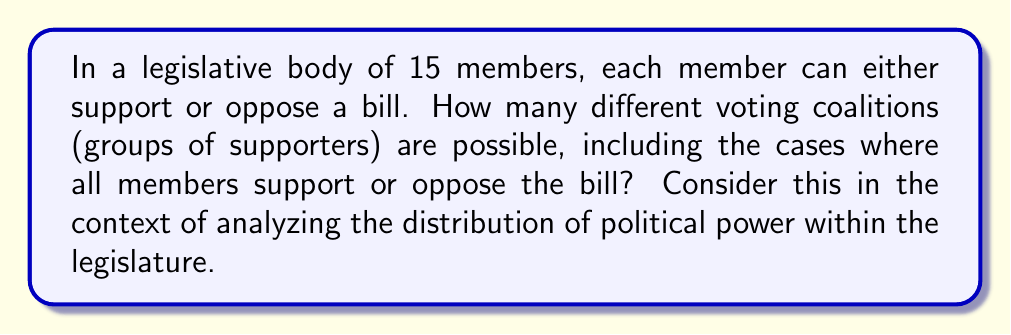Give your solution to this math problem. To solve this problem, we need to follow these steps:

1) Each member has two choices: support or oppose the bill. This is equivalent to choosing whether each member is in the coalition or not.

2) For each member, we have 2 possibilities. Since there are 15 members, and each member's decision is independent, we can use the multiplication principle.

3) The total number of possible coalitions is therefore $2^{15}$. This is because:
   
   $$2 \times 2 \times 2 \times ... \times 2 \text{ (15 times) } = 2^{15}$$

4) We can calculate this:

   $$2^{15} = 32,768$$

5) This number includes all possible coalitions:
   - The empty coalition (no one supports the bill)
   - All coalitions of any size from 1 to 14 members
   - The full coalition (all 15 members support the bill)

This result demonstrates the complexity of potential voting patterns in a legislative body, which is crucial for understanding the dynamics of political power. Each of these coalitions represents a different distribution of support, potentially leading to varied outcomes in the legislative process.
Answer: $2^{15} = 32,768$ 